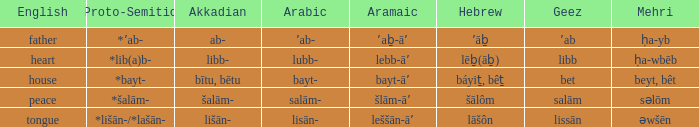How is 'house' translated into proto-semitic from english? *bayt-. 